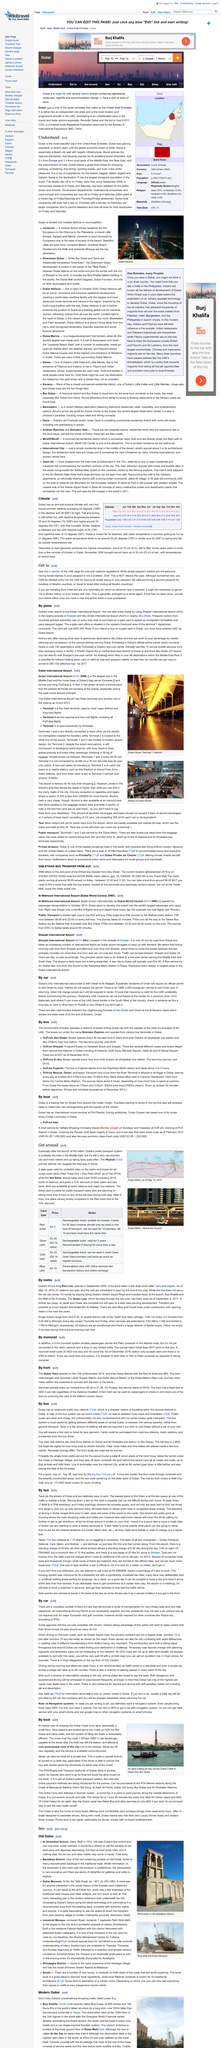Point out several critical features in this image. What is a more convenient method of crossing Dubai Creek? Abraham is a more convenient method of crossing... Abra is used for cross-river trips and is available for private hire. Abra's stations are located along the creek on both the Bur Dubai and Deira sides, providing easy access to the water taxi service. 